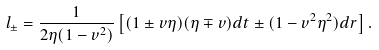Convert formula to latex. <formula><loc_0><loc_0><loc_500><loc_500>l _ { \pm } = \frac { 1 } { 2 \eta ( 1 - v ^ { 2 } ) } \left [ ( 1 \pm v \eta ) ( \eta \mp v ) d t \pm ( 1 - v ^ { 2 } \eta ^ { 2 } ) d r \right ] .</formula> 